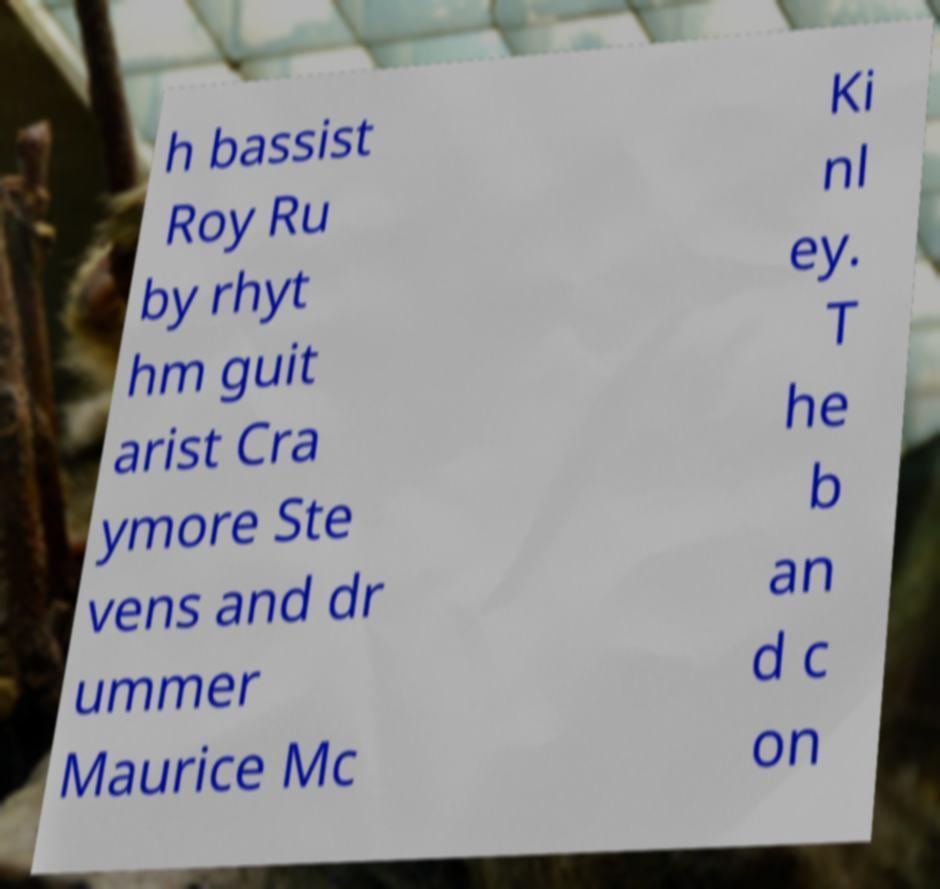Could you extract and type out the text from this image? h bassist Roy Ru by rhyt hm guit arist Cra ymore Ste vens and dr ummer Maurice Mc Ki nl ey. T he b an d c on 